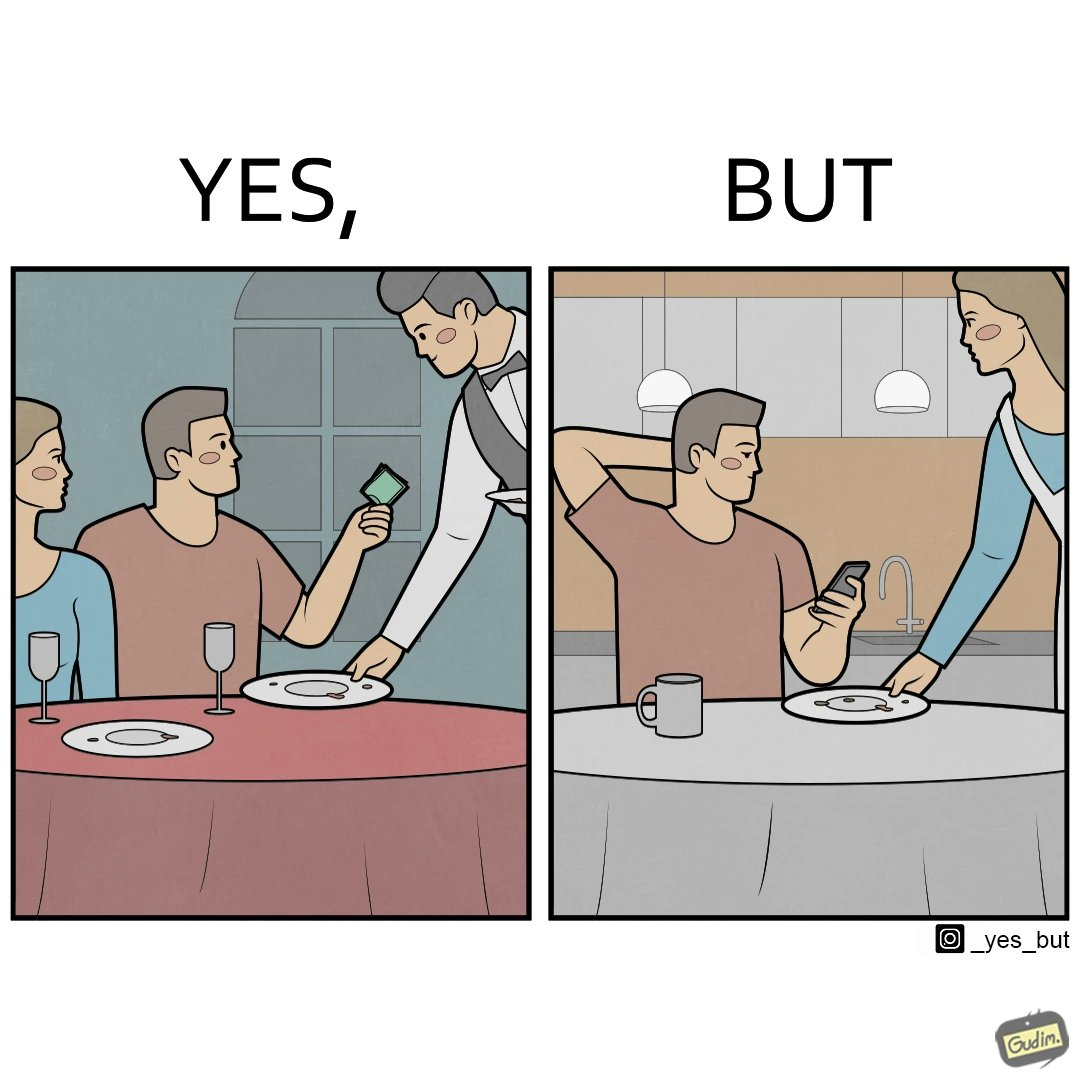Is there satirical content in this image? Yes, this image is satirical. 